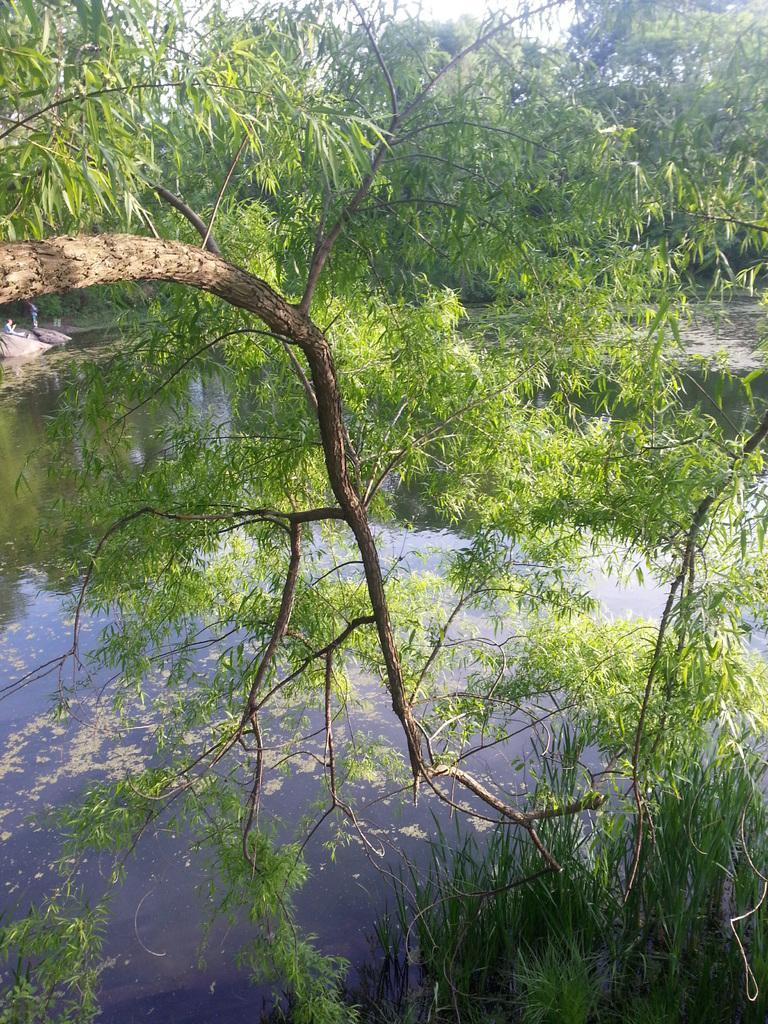Could you give a brief overview of what you see in this image? In this picture we can see water and few trees. 